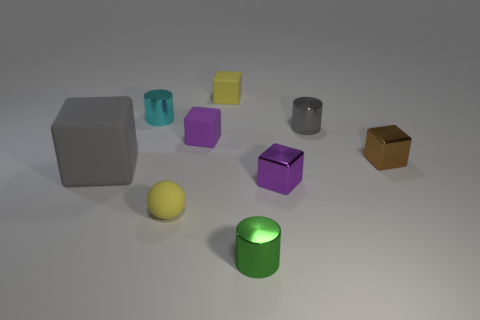How many objects are to the right of the tiny yellow block and in front of the brown object?
Offer a terse response. 2. Do the small ball and the big matte object have the same color?
Your response must be concise. No. There is another purple thing that is the same shape as the tiny purple metal thing; what is its material?
Provide a short and direct response. Rubber. Are there any other things that are the same material as the gray cylinder?
Offer a very short reply. Yes. Are there an equal number of small metallic blocks that are in front of the small brown shiny block and small cubes that are behind the big object?
Ensure brevity in your answer.  No. Is the large gray block made of the same material as the green thing?
Give a very brief answer. No. How many green things are either cylinders or matte objects?
Provide a short and direct response. 1. What number of red metallic objects have the same shape as the small cyan object?
Offer a terse response. 0. What is the material of the cyan thing?
Ensure brevity in your answer.  Metal. Are there the same number of tiny green objects that are behind the gray metallic object and large blue things?
Keep it short and to the point. Yes. 